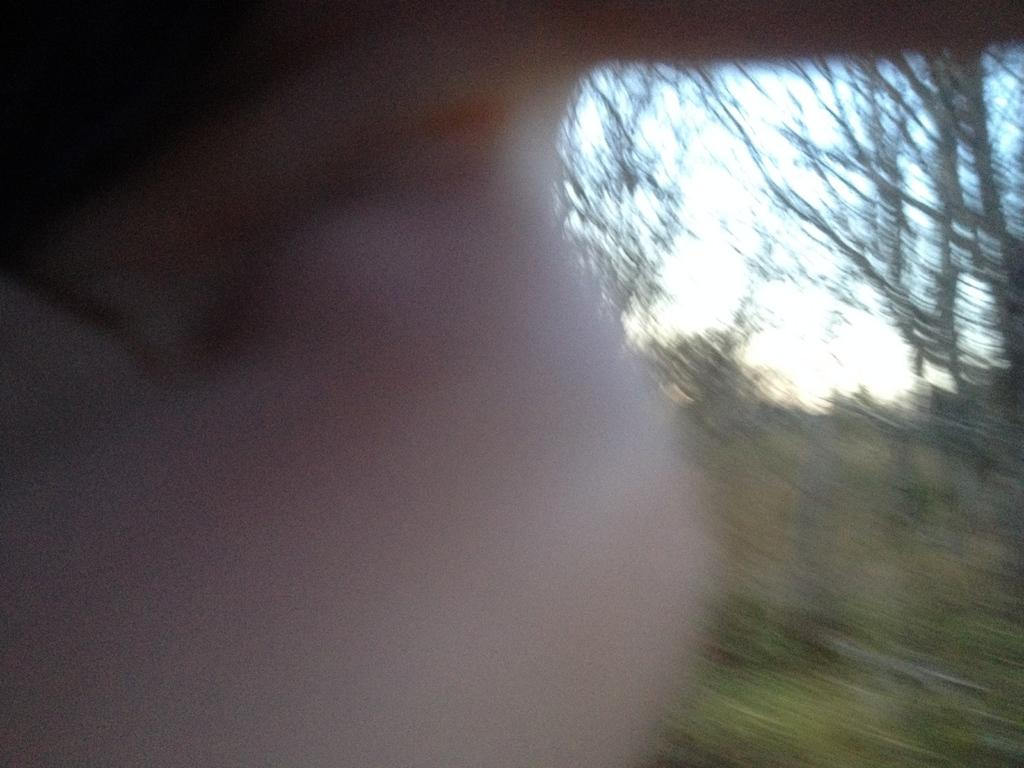What part of a person is visible in the image? There is a person's hand in the image. What can be seen in the background behind the person's hand? Trees are visible behind the person's hand. What is visible in the sky in the image? The sky is visible in the image. What type of scissors is the pig using to cut the rate in the image? There is no pig, scissors, or rate present in the image. 